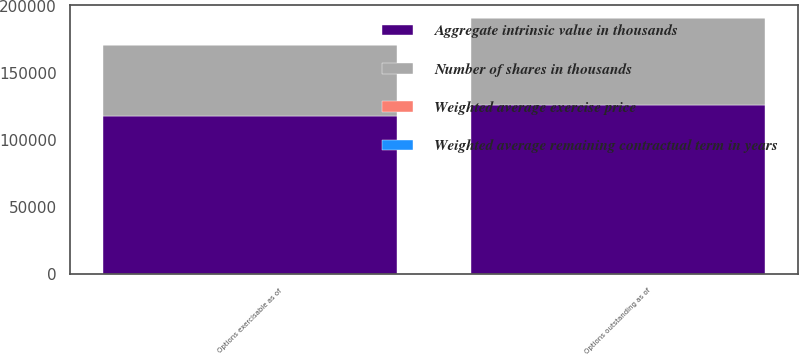Convert chart. <chart><loc_0><loc_0><loc_500><loc_500><stacked_bar_chart><ecel><fcel>Options outstanding as of<fcel>Options exercisable as of<nl><fcel>Number of shares in thousands<fcel>65027<fcel>53209<nl><fcel>Weighted average exercise price<fcel>15.91<fcel>15.49<nl><fcel>Weighted average remaining contractual term in years<fcel>4.77<fcel>4.04<nl><fcel>Aggregate intrinsic value in thousands<fcel>126366<fcel>118042<nl></chart> 